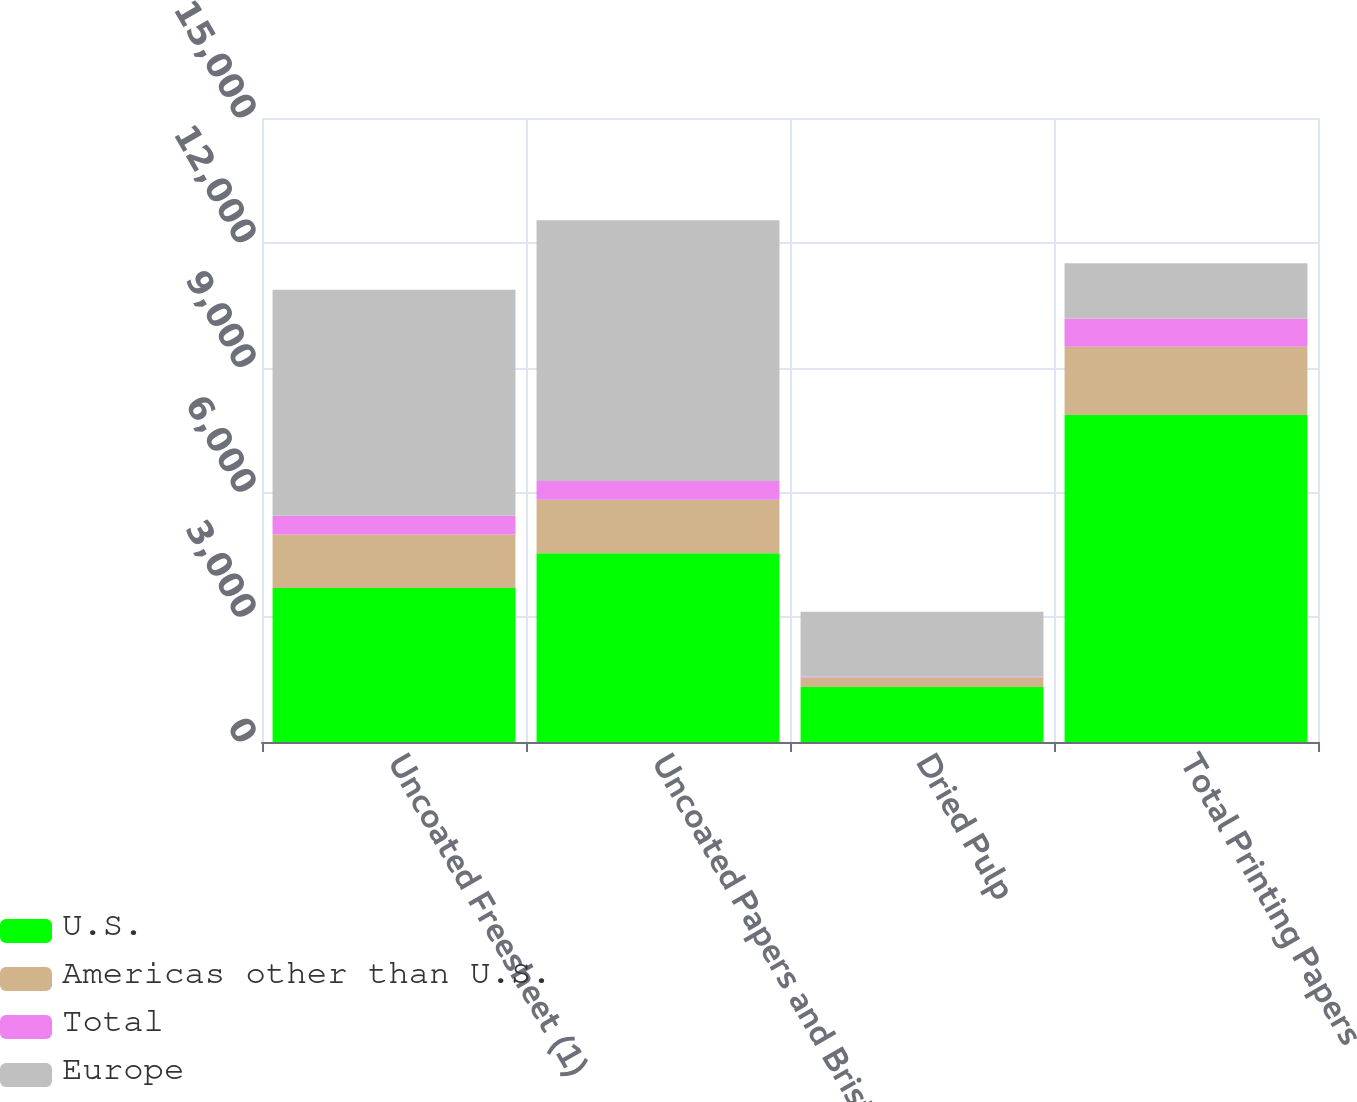Convert chart. <chart><loc_0><loc_0><loc_500><loc_500><stacked_bar_chart><ecel><fcel>Uncoated Freesheet (1)<fcel>Uncoated Papers and Bristols<fcel>Dried Pulp<fcel>Total Printing Papers<nl><fcel>U.S.<fcel>3700<fcel>4535<fcel>1325<fcel>7860<nl><fcel>Americas other than U.S.<fcel>1290<fcel>1290<fcel>228<fcel>1641<nl><fcel>Total<fcel>447<fcel>447<fcel>13<fcel>681<nl><fcel>Europe<fcel>5437<fcel>6272<fcel>1566<fcel>1325<nl></chart> 